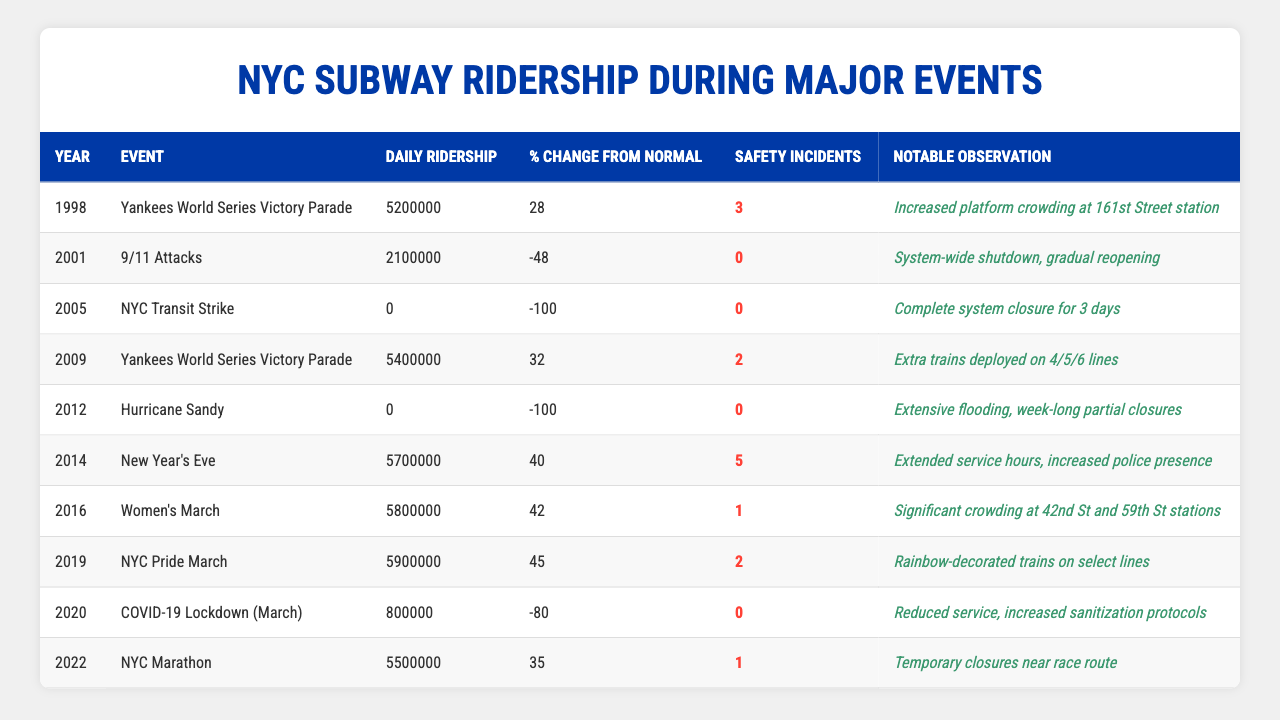What was the daily ridership during the Yankees World Series Victory Parade in 1998? The table indicates that the daily ridership during the Yankees World Series Victory Parade in 1998 was 5,200,000.
Answer: 5,200,000 How much did the daily ridership change from normal during the NYC Transit Strike in 2005? The table shows that there was a 100% decrease in daily ridership during the NYC Transit Strike in 2005, represented as a 0 daily ridership value.
Answer: -100% Did the 9/11 attacks result in any safety incidents? According to the table, there were 0 safety incidents reported during the 9/11 attacks in 2001.
Answer: No What was the highest daily ridership recorded in the table? The table lists daily ridership numbers, with the highest being 5,900,000 during the NYC Pride March in 2019.
Answer: 5,900,000 Which event had the highest percentage change from normal ridership? The NYC Transit Strike in 2005 had the highest percentage change from normal ridership, which was -100%.
Answer: NYC Transit Strike What was the total number of safety incidents recorded during the Yankees World Series Victory Parades in 1998 and 2009? The table indicates that there were 3 safety incidents in 1998 and 2 in 2009, totaling 3 + 2 = 5 safety incidents.
Answer: 5 How many events had a daily ridership of 0? The table lists two events (the NYC Transit Strike in 2005 and Hurricane Sandy in 2012) with a daily ridership of 0.
Answer: 2 What percentage change in ridership occurred during the NYC Marathon in 2022? The table states that the percentage change in ridership during the NYC Marathon in 2022 was 35% from normal levels.
Answer: 35% Did safety incidents increase during the 2014 New Year’s Eve event compared to the Women's March in 2016? The table shows that there were 5 safety incidents during New Year’s Eve in 2014 and 1 during the Women’s March in 2016. Thus, incidents decreased.
Answer: No What is the average daily ridership for the events listed in the table? To find the average, sum all daily ridership values (5,200,000 + 2,100,000 + 0 + 5,400,000 + 0 + 5,700,000 + 5,800,000 + 5,900,000 + 800,000 + 5,500,000) which equals 36,400,000, then divide by the number of events (10), yielding an average of 3,640,000.
Answer: 3,640,000 